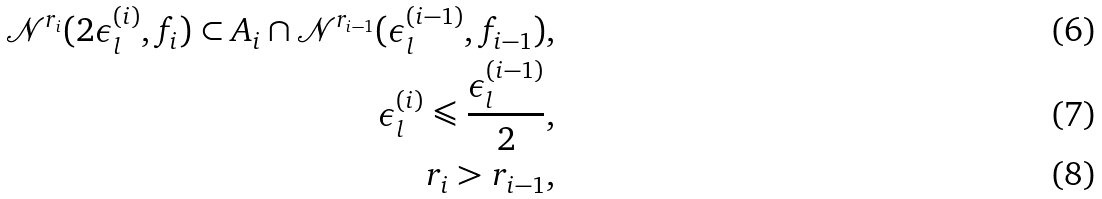<formula> <loc_0><loc_0><loc_500><loc_500>\mathcal { N } ^ { r _ { i } } ( 2 \epsilon ^ { ( i ) } _ { l } , f _ { i } ) \subset A _ { i } \cap \mathcal { N } ^ { r _ { i - 1 } } ( \epsilon ^ { ( i - 1 ) } _ { l } , f _ { i - 1 } ) , \\ \epsilon ^ { ( i ) } _ { l } \leqslant \frac { \epsilon ^ { ( i - 1 ) } _ { l } } { 2 } , \\ r _ { i } > r _ { i - 1 } ,</formula> 